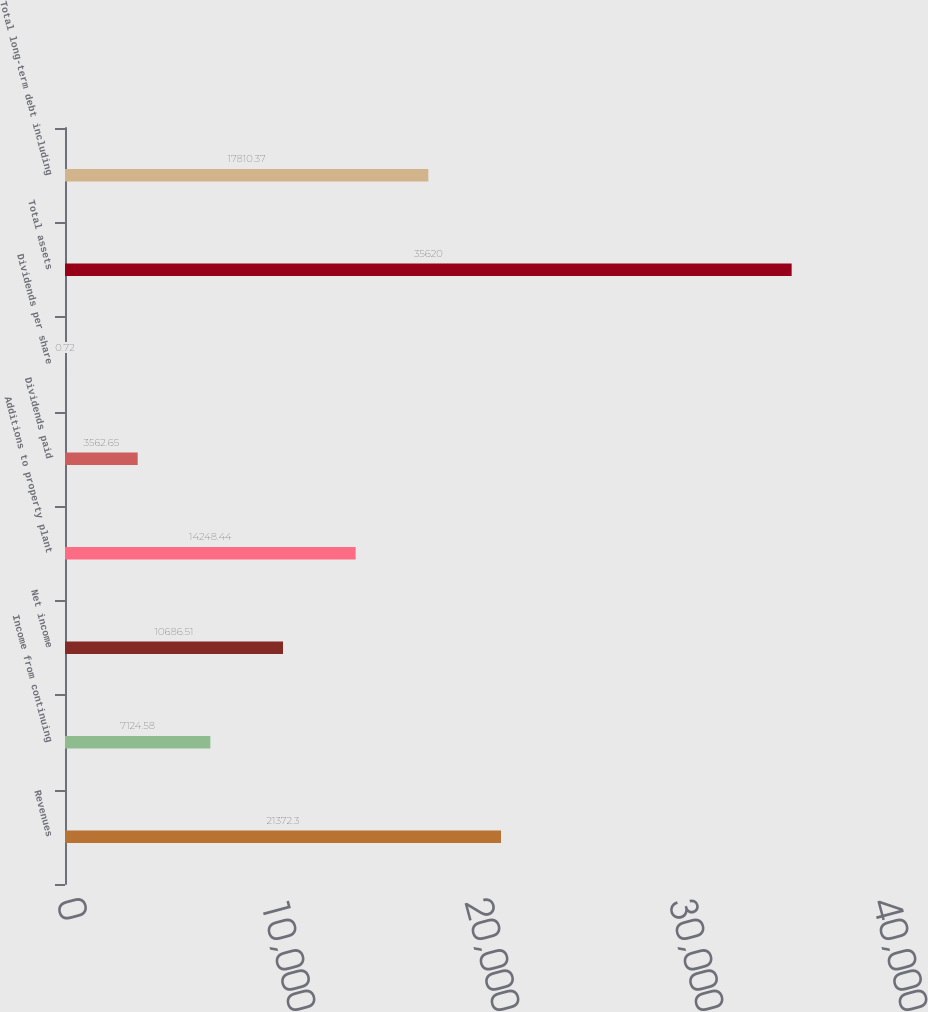<chart> <loc_0><loc_0><loc_500><loc_500><bar_chart><fcel>Revenues<fcel>Income from continuing<fcel>Net income<fcel>Additions to property plant<fcel>Dividends paid<fcel>Dividends per share<fcel>Total assets<fcel>Total long-term debt including<nl><fcel>21372.3<fcel>7124.58<fcel>10686.5<fcel>14248.4<fcel>3562.65<fcel>0.72<fcel>35620<fcel>17810.4<nl></chart> 